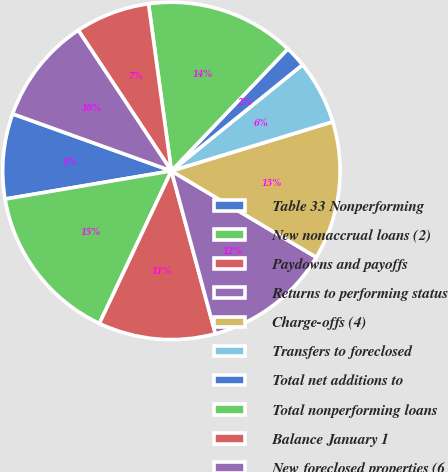<chart> <loc_0><loc_0><loc_500><loc_500><pie_chart><fcel>Table 33 Nonperforming<fcel>New nonaccrual loans (2)<fcel>Paydowns and payoffs<fcel>Returns to performing status<fcel>Charge-offs (4)<fcel>Transfers to foreclosed<fcel>Total net additions to<fcel>Total nonperforming loans<fcel>Balance January 1<fcel>New foreclosed properties (6<nl><fcel>8.16%<fcel>15.31%<fcel>11.22%<fcel>12.24%<fcel>13.26%<fcel>6.12%<fcel>2.04%<fcel>14.29%<fcel>7.14%<fcel>10.2%<nl></chart> 